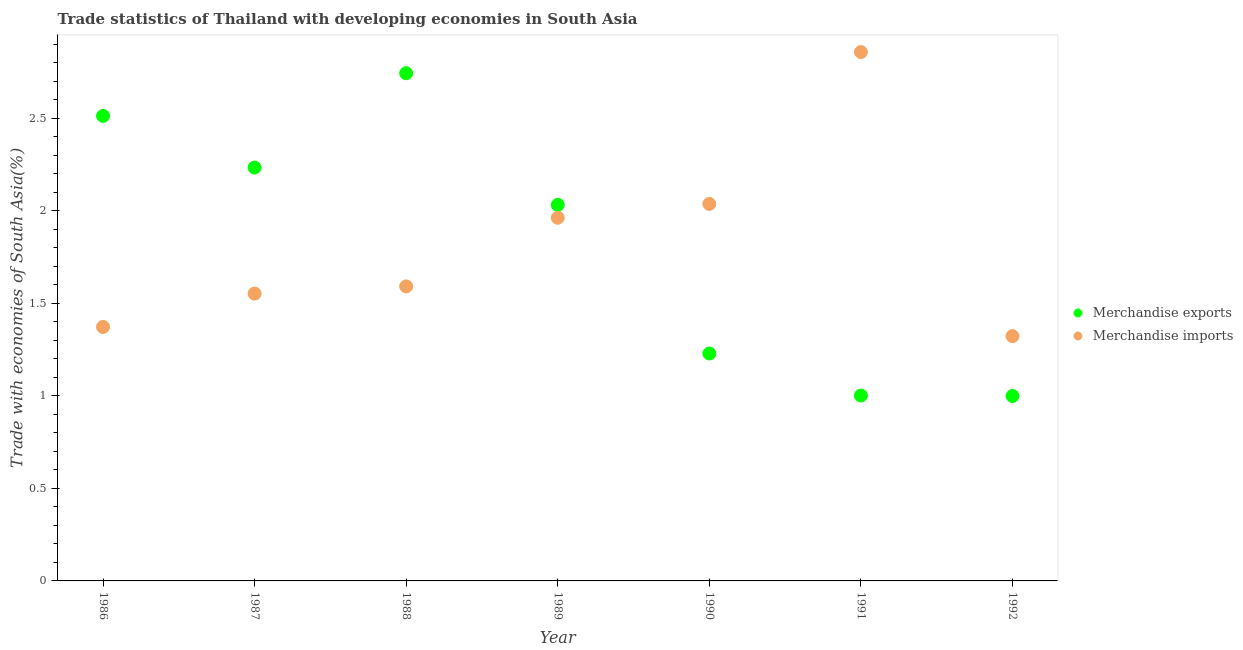Is the number of dotlines equal to the number of legend labels?
Your answer should be compact. Yes. What is the merchandise imports in 1989?
Ensure brevity in your answer.  1.96. Across all years, what is the maximum merchandise imports?
Your response must be concise. 2.86. Across all years, what is the minimum merchandise exports?
Give a very brief answer. 1. In which year was the merchandise exports minimum?
Offer a terse response. 1992. What is the total merchandise imports in the graph?
Offer a very short reply. 12.7. What is the difference between the merchandise exports in 1986 and that in 1990?
Keep it short and to the point. 1.28. What is the difference between the merchandise imports in 1987 and the merchandise exports in 1988?
Give a very brief answer. -1.19. What is the average merchandise imports per year?
Your answer should be very brief. 1.81. In the year 1986, what is the difference between the merchandise exports and merchandise imports?
Provide a short and direct response. 1.14. What is the ratio of the merchandise imports in 1986 to that in 1990?
Make the answer very short. 0.67. What is the difference between the highest and the second highest merchandise exports?
Your response must be concise. 0.23. What is the difference between the highest and the lowest merchandise exports?
Keep it short and to the point. 1.74. Is the sum of the merchandise imports in 1990 and 1991 greater than the maximum merchandise exports across all years?
Make the answer very short. Yes. Is the merchandise exports strictly greater than the merchandise imports over the years?
Offer a very short reply. No. How many years are there in the graph?
Provide a short and direct response. 7. What is the difference between two consecutive major ticks on the Y-axis?
Your response must be concise. 0.5. Does the graph contain grids?
Your answer should be very brief. No. What is the title of the graph?
Provide a short and direct response. Trade statistics of Thailand with developing economies in South Asia. Does "Register a property" appear as one of the legend labels in the graph?
Offer a terse response. No. What is the label or title of the Y-axis?
Keep it short and to the point. Trade with economies of South Asia(%). What is the Trade with economies of South Asia(%) of Merchandise exports in 1986?
Provide a succinct answer. 2.51. What is the Trade with economies of South Asia(%) of Merchandise imports in 1986?
Your answer should be very brief. 1.37. What is the Trade with economies of South Asia(%) of Merchandise exports in 1987?
Give a very brief answer. 2.23. What is the Trade with economies of South Asia(%) of Merchandise imports in 1987?
Your answer should be very brief. 1.55. What is the Trade with economies of South Asia(%) in Merchandise exports in 1988?
Offer a very short reply. 2.74. What is the Trade with economies of South Asia(%) of Merchandise imports in 1988?
Offer a terse response. 1.59. What is the Trade with economies of South Asia(%) of Merchandise exports in 1989?
Ensure brevity in your answer.  2.03. What is the Trade with economies of South Asia(%) in Merchandise imports in 1989?
Give a very brief answer. 1.96. What is the Trade with economies of South Asia(%) in Merchandise exports in 1990?
Provide a succinct answer. 1.23. What is the Trade with economies of South Asia(%) in Merchandise imports in 1990?
Your response must be concise. 2.04. What is the Trade with economies of South Asia(%) in Merchandise exports in 1991?
Your answer should be very brief. 1. What is the Trade with economies of South Asia(%) of Merchandise imports in 1991?
Offer a very short reply. 2.86. What is the Trade with economies of South Asia(%) in Merchandise exports in 1992?
Keep it short and to the point. 1. What is the Trade with economies of South Asia(%) in Merchandise imports in 1992?
Your response must be concise. 1.32. Across all years, what is the maximum Trade with economies of South Asia(%) of Merchandise exports?
Provide a succinct answer. 2.74. Across all years, what is the maximum Trade with economies of South Asia(%) of Merchandise imports?
Offer a terse response. 2.86. Across all years, what is the minimum Trade with economies of South Asia(%) of Merchandise exports?
Give a very brief answer. 1. Across all years, what is the minimum Trade with economies of South Asia(%) in Merchandise imports?
Make the answer very short. 1.32. What is the total Trade with economies of South Asia(%) in Merchandise exports in the graph?
Your answer should be compact. 12.76. What is the total Trade with economies of South Asia(%) of Merchandise imports in the graph?
Ensure brevity in your answer.  12.7. What is the difference between the Trade with economies of South Asia(%) of Merchandise exports in 1986 and that in 1987?
Ensure brevity in your answer.  0.28. What is the difference between the Trade with economies of South Asia(%) in Merchandise imports in 1986 and that in 1987?
Provide a succinct answer. -0.18. What is the difference between the Trade with economies of South Asia(%) in Merchandise exports in 1986 and that in 1988?
Provide a short and direct response. -0.23. What is the difference between the Trade with economies of South Asia(%) of Merchandise imports in 1986 and that in 1988?
Provide a succinct answer. -0.22. What is the difference between the Trade with economies of South Asia(%) of Merchandise exports in 1986 and that in 1989?
Keep it short and to the point. 0.48. What is the difference between the Trade with economies of South Asia(%) of Merchandise imports in 1986 and that in 1989?
Your answer should be very brief. -0.59. What is the difference between the Trade with economies of South Asia(%) in Merchandise exports in 1986 and that in 1990?
Provide a short and direct response. 1.28. What is the difference between the Trade with economies of South Asia(%) in Merchandise imports in 1986 and that in 1990?
Give a very brief answer. -0.67. What is the difference between the Trade with economies of South Asia(%) in Merchandise exports in 1986 and that in 1991?
Make the answer very short. 1.51. What is the difference between the Trade with economies of South Asia(%) in Merchandise imports in 1986 and that in 1991?
Give a very brief answer. -1.49. What is the difference between the Trade with economies of South Asia(%) in Merchandise exports in 1986 and that in 1992?
Your answer should be very brief. 1.51. What is the difference between the Trade with economies of South Asia(%) of Merchandise imports in 1986 and that in 1992?
Provide a succinct answer. 0.05. What is the difference between the Trade with economies of South Asia(%) in Merchandise exports in 1987 and that in 1988?
Provide a succinct answer. -0.51. What is the difference between the Trade with economies of South Asia(%) in Merchandise imports in 1987 and that in 1988?
Ensure brevity in your answer.  -0.04. What is the difference between the Trade with economies of South Asia(%) of Merchandise exports in 1987 and that in 1989?
Offer a terse response. 0.2. What is the difference between the Trade with economies of South Asia(%) in Merchandise imports in 1987 and that in 1989?
Your response must be concise. -0.41. What is the difference between the Trade with economies of South Asia(%) of Merchandise exports in 1987 and that in 1990?
Provide a succinct answer. 1.01. What is the difference between the Trade with economies of South Asia(%) in Merchandise imports in 1987 and that in 1990?
Your answer should be very brief. -0.48. What is the difference between the Trade with economies of South Asia(%) of Merchandise exports in 1987 and that in 1991?
Ensure brevity in your answer.  1.23. What is the difference between the Trade with economies of South Asia(%) of Merchandise imports in 1987 and that in 1991?
Your answer should be compact. -1.31. What is the difference between the Trade with economies of South Asia(%) of Merchandise exports in 1987 and that in 1992?
Keep it short and to the point. 1.23. What is the difference between the Trade with economies of South Asia(%) of Merchandise imports in 1987 and that in 1992?
Your answer should be very brief. 0.23. What is the difference between the Trade with economies of South Asia(%) of Merchandise exports in 1988 and that in 1989?
Your answer should be very brief. 0.71. What is the difference between the Trade with economies of South Asia(%) in Merchandise imports in 1988 and that in 1989?
Keep it short and to the point. -0.37. What is the difference between the Trade with economies of South Asia(%) in Merchandise exports in 1988 and that in 1990?
Provide a succinct answer. 1.52. What is the difference between the Trade with economies of South Asia(%) of Merchandise imports in 1988 and that in 1990?
Make the answer very short. -0.45. What is the difference between the Trade with economies of South Asia(%) in Merchandise exports in 1988 and that in 1991?
Your answer should be very brief. 1.74. What is the difference between the Trade with economies of South Asia(%) of Merchandise imports in 1988 and that in 1991?
Make the answer very short. -1.27. What is the difference between the Trade with economies of South Asia(%) in Merchandise exports in 1988 and that in 1992?
Give a very brief answer. 1.75. What is the difference between the Trade with economies of South Asia(%) in Merchandise imports in 1988 and that in 1992?
Make the answer very short. 0.27. What is the difference between the Trade with economies of South Asia(%) in Merchandise exports in 1989 and that in 1990?
Keep it short and to the point. 0.8. What is the difference between the Trade with economies of South Asia(%) in Merchandise imports in 1989 and that in 1990?
Your answer should be very brief. -0.07. What is the difference between the Trade with economies of South Asia(%) in Merchandise exports in 1989 and that in 1991?
Your response must be concise. 1.03. What is the difference between the Trade with economies of South Asia(%) in Merchandise imports in 1989 and that in 1991?
Your answer should be compact. -0.9. What is the difference between the Trade with economies of South Asia(%) in Merchandise exports in 1989 and that in 1992?
Offer a very short reply. 1.03. What is the difference between the Trade with economies of South Asia(%) of Merchandise imports in 1989 and that in 1992?
Your answer should be very brief. 0.64. What is the difference between the Trade with economies of South Asia(%) in Merchandise exports in 1990 and that in 1991?
Your answer should be compact. 0.23. What is the difference between the Trade with economies of South Asia(%) in Merchandise imports in 1990 and that in 1991?
Offer a terse response. -0.82. What is the difference between the Trade with economies of South Asia(%) in Merchandise exports in 1990 and that in 1992?
Provide a short and direct response. 0.23. What is the difference between the Trade with economies of South Asia(%) in Merchandise imports in 1990 and that in 1992?
Provide a short and direct response. 0.71. What is the difference between the Trade with economies of South Asia(%) in Merchandise exports in 1991 and that in 1992?
Provide a succinct answer. 0. What is the difference between the Trade with economies of South Asia(%) of Merchandise imports in 1991 and that in 1992?
Give a very brief answer. 1.54. What is the difference between the Trade with economies of South Asia(%) of Merchandise exports in 1986 and the Trade with economies of South Asia(%) of Merchandise imports in 1987?
Your answer should be very brief. 0.96. What is the difference between the Trade with economies of South Asia(%) in Merchandise exports in 1986 and the Trade with economies of South Asia(%) in Merchandise imports in 1988?
Offer a very short reply. 0.92. What is the difference between the Trade with economies of South Asia(%) of Merchandise exports in 1986 and the Trade with economies of South Asia(%) of Merchandise imports in 1989?
Ensure brevity in your answer.  0.55. What is the difference between the Trade with economies of South Asia(%) of Merchandise exports in 1986 and the Trade with economies of South Asia(%) of Merchandise imports in 1990?
Provide a short and direct response. 0.48. What is the difference between the Trade with economies of South Asia(%) of Merchandise exports in 1986 and the Trade with economies of South Asia(%) of Merchandise imports in 1991?
Offer a terse response. -0.34. What is the difference between the Trade with economies of South Asia(%) of Merchandise exports in 1986 and the Trade with economies of South Asia(%) of Merchandise imports in 1992?
Provide a succinct answer. 1.19. What is the difference between the Trade with economies of South Asia(%) in Merchandise exports in 1987 and the Trade with economies of South Asia(%) in Merchandise imports in 1988?
Offer a terse response. 0.64. What is the difference between the Trade with economies of South Asia(%) in Merchandise exports in 1987 and the Trade with economies of South Asia(%) in Merchandise imports in 1989?
Your answer should be compact. 0.27. What is the difference between the Trade with economies of South Asia(%) of Merchandise exports in 1987 and the Trade with economies of South Asia(%) of Merchandise imports in 1990?
Ensure brevity in your answer.  0.2. What is the difference between the Trade with economies of South Asia(%) in Merchandise exports in 1987 and the Trade with economies of South Asia(%) in Merchandise imports in 1991?
Make the answer very short. -0.62. What is the difference between the Trade with economies of South Asia(%) of Merchandise exports in 1987 and the Trade with economies of South Asia(%) of Merchandise imports in 1992?
Your answer should be very brief. 0.91. What is the difference between the Trade with economies of South Asia(%) in Merchandise exports in 1988 and the Trade with economies of South Asia(%) in Merchandise imports in 1989?
Provide a succinct answer. 0.78. What is the difference between the Trade with economies of South Asia(%) of Merchandise exports in 1988 and the Trade with economies of South Asia(%) of Merchandise imports in 1990?
Provide a short and direct response. 0.71. What is the difference between the Trade with economies of South Asia(%) in Merchandise exports in 1988 and the Trade with economies of South Asia(%) in Merchandise imports in 1991?
Your response must be concise. -0.11. What is the difference between the Trade with economies of South Asia(%) in Merchandise exports in 1988 and the Trade with economies of South Asia(%) in Merchandise imports in 1992?
Offer a very short reply. 1.42. What is the difference between the Trade with economies of South Asia(%) in Merchandise exports in 1989 and the Trade with economies of South Asia(%) in Merchandise imports in 1990?
Ensure brevity in your answer.  -0.01. What is the difference between the Trade with economies of South Asia(%) in Merchandise exports in 1989 and the Trade with economies of South Asia(%) in Merchandise imports in 1991?
Provide a short and direct response. -0.83. What is the difference between the Trade with economies of South Asia(%) of Merchandise exports in 1989 and the Trade with economies of South Asia(%) of Merchandise imports in 1992?
Keep it short and to the point. 0.71. What is the difference between the Trade with economies of South Asia(%) of Merchandise exports in 1990 and the Trade with economies of South Asia(%) of Merchandise imports in 1991?
Ensure brevity in your answer.  -1.63. What is the difference between the Trade with economies of South Asia(%) of Merchandise exports in 1990 and the Trade with economies of South Asia(%) of Merchandise imports in 1992?
Your answer should be compact. -0.09. What is the difference between the Trade with economies of South Asia(%) of Merchandise exports in 1991 and the Trade with economies of South Asia(%) of Merchandise imports in 1992?
Offer a very short reply. -0.32. What is the average Trade with economies of South Asia(%) in Merchandise exports per year?
Offer a very short reply. 1.82. What is the average Trade with economies of South Asia(%) of Merchandise imports per year?
Your answer should be very brief. 1.81. In the year 1986, what is the difference between the Trade with economies of South Asia(%) of Merchandise exports and Trade with economies of South Asia(%) of Merchandise imports?
Your response must be concise. 1.14. In the year 1987, what is the difference between the Trade with economies of South Asia(%) of Merchandise exports and Trade with economies of South Asia(%) of Merchandise imports?
Keep it short and to the point. 0.68. In the year 1988, what is the difference between the Trade with economies of South Asia(%) of Merchandise exports and Trade with economies of South Asia(%) of Merchandise imports?
Make the answer very short. 1.15. In the year 1989, what is the difference between the Trade with economies of South Asia(%) in Merchandise exports and Trade with economies of South Asia(%) in Merchandise imports?
Provide a short and direct response. 0.07. In the year 1990, what is the difference between the Trade with economies of South Asia(%) of Merchandise exports and Trade with economies of South Asia(%) of Merchandise imports?
Offer a very short reply. -0.81. In the year 1991, what is the difference between the Trade with economies of South Asia(%) in Merchandise exports and Trade with economies of South Asia(%) in Merchandise imports?
Your answer should be very brief. -1.86. In the year 1992, what is the difference between the Trade with economies of South Asia(%) in Merchandise exports and Trade with economies of South Asia(%) in Merchandise imports?
Provide a succinct answer. -0.32. What is the ratio of the Trade with economies of South Asia(%) in Merchandise imports in 1986 to that in 1987?
Offer a very short reply. 0.88. What is the ratio of the Trade with economies of South Asia(%) of Merchandise exports in 1986 to that in 1988?
Your response must be concise. 0.92. What is the ratio of the Trade with economies of South Asia(%) in Merchandise imports in 1986 to that in 1988?
Keep it short and to the point. 0.86. What is the ratio of the Trade with economies of South Asia(%) of Merchandise exports in 1986 to that in 1989?
Offer a terse response. 1.24. What is the ratio of the Trade with economies of South Asia(%) in Merchandise imports in 1986 to that in 1989?
Your response must be concise. 0.7. What is the ratio of the Trade with economies of South Asia(%) of Merchandise exports in 1986 to that in 1990?
Offer a terse response. 2.04. What is the ratio of the Trade with economies of South Asia(%) in Merchandise imports in 1986 to that in 1990?
Ensure brevity in your answer.  0.67. What is the ratio of the Trade with economies of South Asia(%) of Merchandise exports in 1986 to that in 1991?
Keep it short and to the point. 2.51. What is the ratio of the Trade with economies of South Asia(%) of Merchandise imports in 1986 to that in 1991?
Ensure brevity in your answer.  0.48. What is the ratio of the Trade with economies of South Asia(%) of Merchandise exports in 1986 to that in 1992?
Make the answer very short. 2.51. What is the ratio of the Trade with economies of South Asia(%) in Merchandise imports in 1986 to that in 1992?
Offer a very short reply. 1.04. What is the ratio of the Trade with economies of South Asia(%) in Merchandise exports in 1987 to that in 1988?
Your answer should be compact. 0.81. What is the ratio of the Trade with economies of South Asia(%) of Merchandise imports in 1987 to that in 1988?
Make the answer very short. 0.98. What is the ratio of the Trade with economies of South Asia(%) of Merchandise exports in 1987 to that in 1989?
Offer a terse response. 1.1. What is the ratio of the Trade with economies of South Asia(%) of Merchandise imports in 1987 to that in 1989?
Provide a succinct answer. 0.79. What is the ratio of the Trade with economies of South Asia(%) in Merchandise exports in 1987 to that in 1990?
Provide a short and direct response. 1.82. What is the ratio of the Trade with economies of South Asia(%) in Merchandise imports in 1987 to that in 1990?
Offer a terse response. 0.76. What is the ratio of the Trade with economies of South Asia(%) in Merchandise exports in 1987 to that in 1991?
Provide a succinct answer. 2.23. What is the ratio of the Trade with economies of South Asia(%) of Merchandise imports in 1987 to that in 1991?
Give a very brief answer. 0.54. What is the ratio of the Trade with economies of South Asia(%) in Merchandise exports in 1987 to that in 1992?
Your answer should be very brief. 2.24. What is the ratio of the Trade with economies of South Asia(%) in Merchandise imports in 1987 to that in 1992?
Make the answer very short. 1.17. What is the ratio of the Trade with economies of South Asia(%) of Merchandise exports in 1988 to that in 1989?
Offer a very short reply. 1.35. What is the ratio of the Trade with economies of South Asia(%) of Merchandise imports in 1988 to that in 1989?
Provide a succinct answer. 0.81. What is the ratio of the Trade with economies of South Asia(%) of Merchandise exports in 1988 to that in 1990?
Offer a terse response. 2.23. What is the ratio of the Trade with economies of South Asia(%) in Merchandise imports in 1988 to that in 1990?
Your answer should be very brief. 0.78. What is the ratio of the Trade with economies of South Asia(%) of Merchandise exports in 1988 to that in 1991?
Ensure brevity in your answer.  2.74. What is the ratio of the Trade with economies of South Asia(%) in Merchandise imports in 1988 to that in 1991?
Provide a succinct answer. 0.56. What is the ratio of the Trade with economies of South Asia(%) in Merchandise exports in 1988 to that in 1992?
Offer a very short reply. 2.75. What is the ratio of the Trade with economies of South Asia(%) of Merchandise imports in 1988 to that in 1992?
Ensure brevity in your answer.  1.2. What is the ratio of the Trade with economies of South Asia(%) of Merchandise exports in 1989 to that in 1990?
Make the answer very short. 1.65. What is the ratio of the Trade with economies of South Asia(%) in Merchandise imports in 1989 to that in 1990?
Offer a terse response. 0.96. What is the ratio of the Trade with economies of South Asia(%) in Merchandise exports in 1989 to that in 1991?
Provide a short and direct response. 2.03. What is the ratio of the Trade with economies of South Asia(%) of Merchandise imports in 1989 to that in 1991?
Provide a succinct answer. 0.69. What is the ratio of the Trade with economies of South Asia(%) in Merchandise exports in 1989 to that in 1992?
Make the answer very short. 2.03. What is the ratio of the Trade with economies of South Asia(%) of Merchandise imports in 1989 to that in 1992?
Offer a very short reply. 1.48. What is the ratio of the Trade with economies of South Asia(%) in Merchandise exports in 1990 to that in 1991?
Ensure brevity in your answer.  1.23. What is the ratio of the Trade with economies of South Asia(%) of Merchandise imports in 1990 to that in 1991?
Your answer should be very brief. 0.71. What is the ratio of the Trade with economies of South Asia(%) of Merchandise exports in 1990 to that in 1992?
Your answer should be compact. 1.23. What is the ratio of the Trade with economies of South Asia(%) in Merchandise imports in 1990 to that in 1992?
Offer a very short reply. 1.54. What is the ratio of the Trade with economies of South Asia(%) in Merchandise exports in 1991 to that in 1992?
Offer a very short reply. 1. What is the ratio of the Trade with economies of South Asia(%) of Merchandise imports in 1991 to that in 1992?
Ensure brevity in your answer.  2.16. What is the difference between the highest and the second highest Trade with economies of South Asia(%) in Merchandise exports?
Ensure brevity in your answer.  0.23. What is the difference between the highest and the second highest Trade with economies of South Asia(%) of Merchandise imports?
Your answer should be very brief. 0.82. What is the difference between the highest and the lowest Trade with economies of South Asia(%) of Merchandise exports?
Ensure brevity in your answer.  1.75. What is the difference between the highest and the lowest Trade with economies of South Asia(%) of Merchandise imports?
Provide a succinct answer. 1.54. 